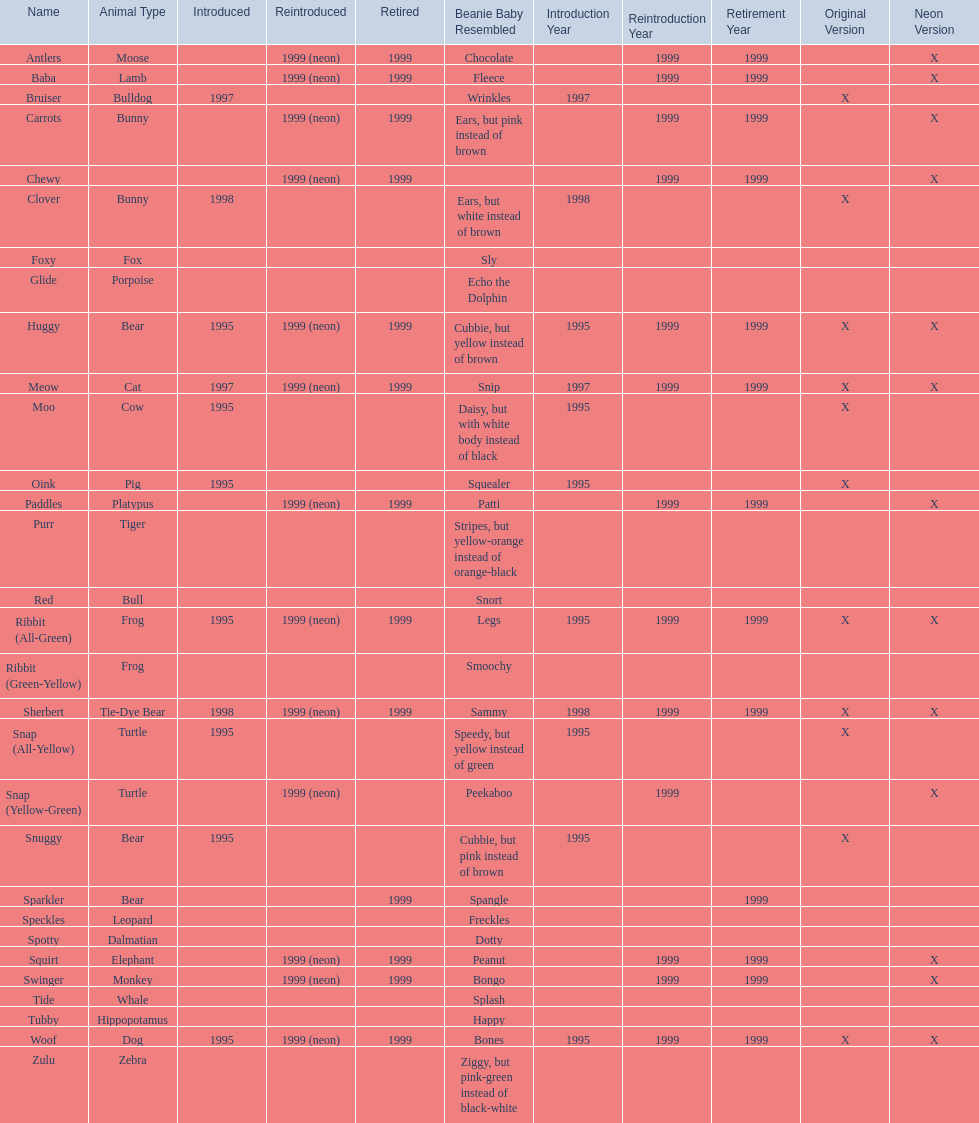What animals are pillow pals? Moose, Lamb, Bulldog, Bunny, Bunny, Fox, Porpoise, Bear, Cat, Cow, Pig, Platypus, Tiger, Bull, Frog, Frog, Tie-Dye Bear, Turtle, Turtle, Bear, Bear, Leopard, Dalmatian, Elephant, Monkey, Whale, Hippopotamus, Dog, Zebra. What is the name of the dalmatian? Spotty. 